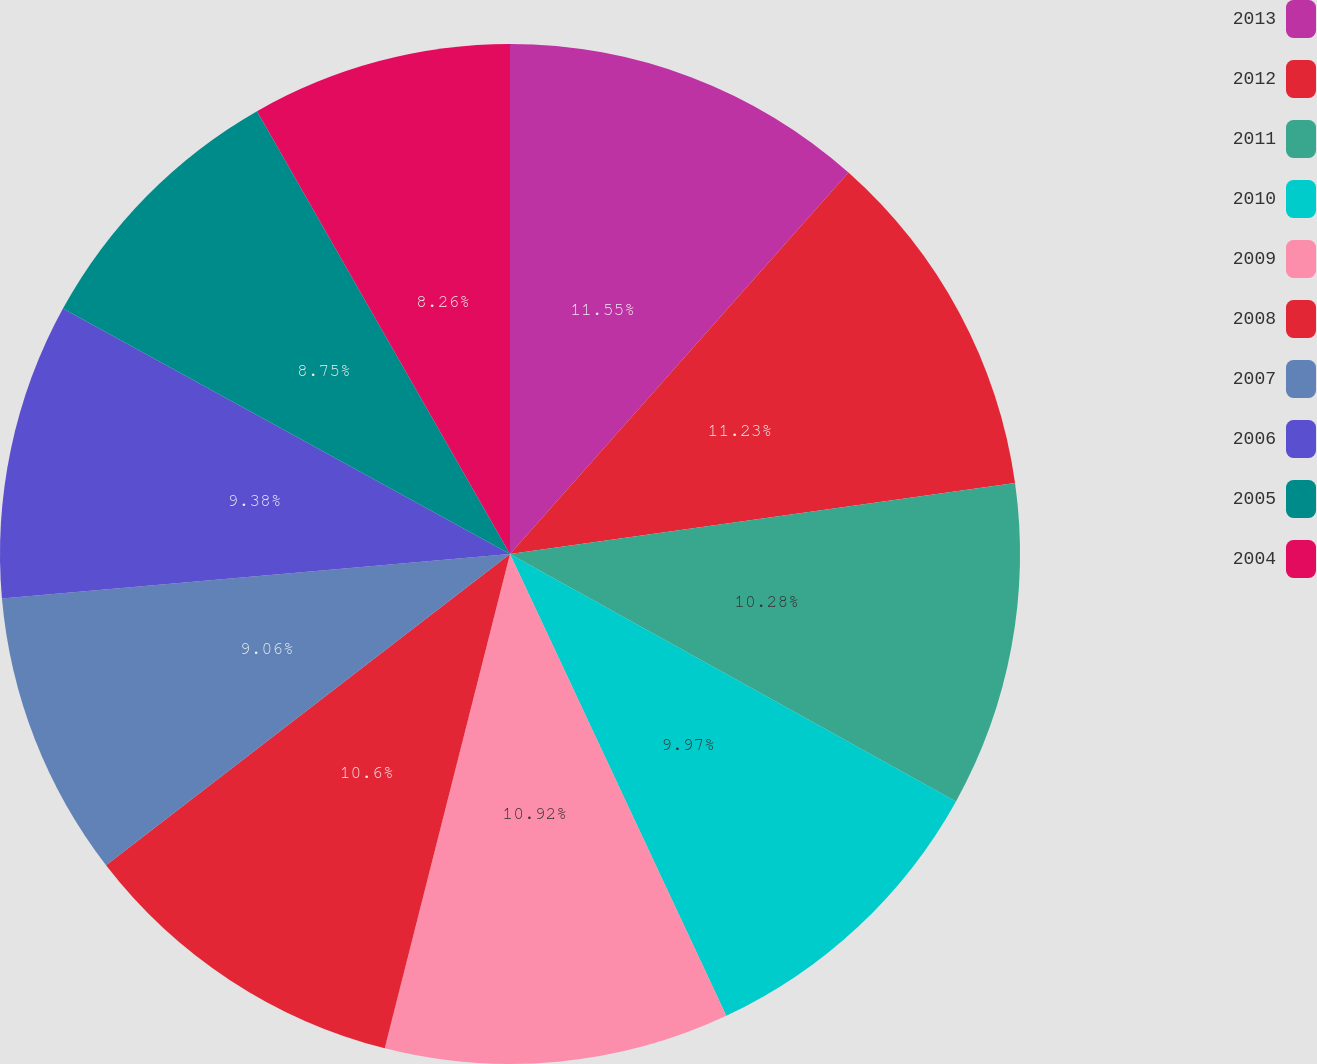Convert chart. <chart><loc_0><loc_0><loc_500><loc_500><pie_chart><fcel>2013<fcel>2012<fcel>2011<fcel>2010<fcel>2009<fcel>2008<fcel>2007<fcel>2006<fcel>2005<fcel>2004<nl><fcel>11.55%<fcel>11.23%<fcel>10.28%<fcel>9.97%<fcel>10.92%<fcel>10.6%<fcel>9.06%<fcel>9.38%<fcel>8.75%<fcel>8.26%<nl></chart> 